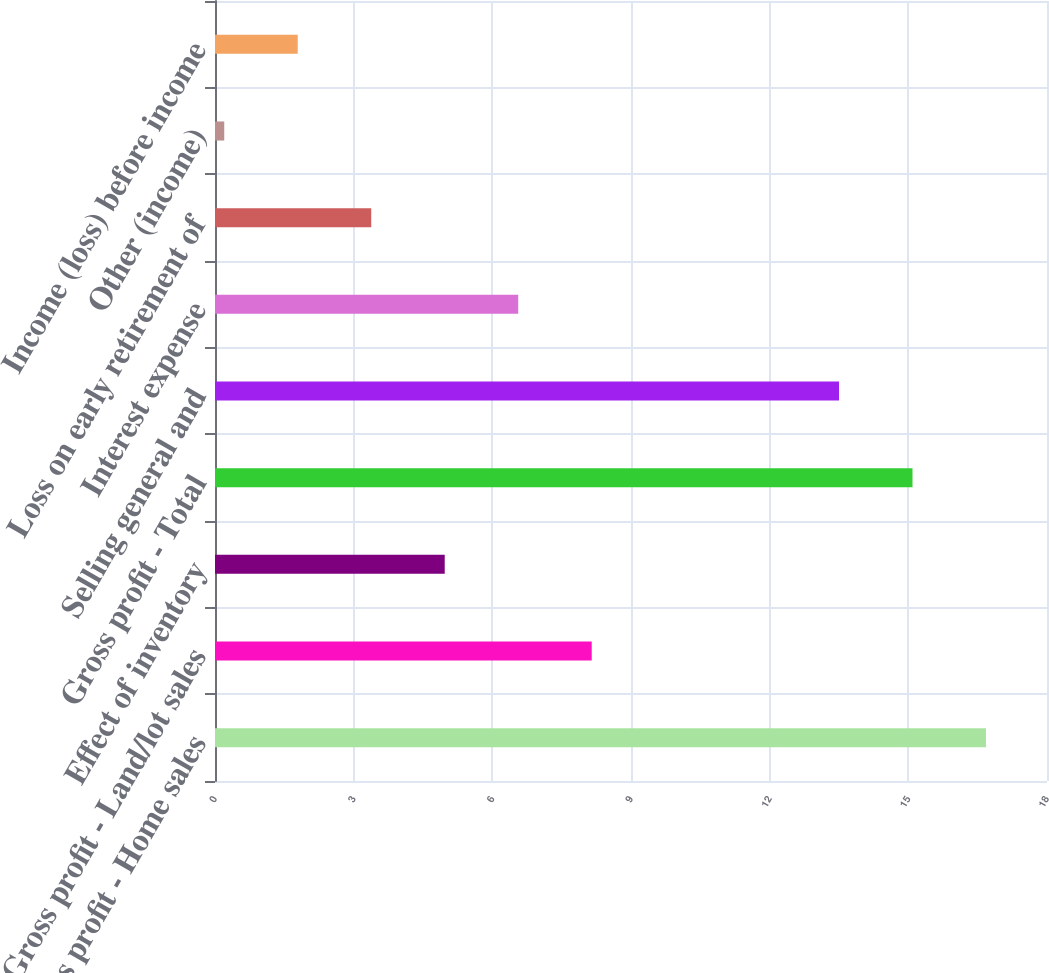Convert chart to OTSL. <chart><loc_0><loc_0><loc_500><loc_500><bar_chart><fcel>Gross profit - Home sales<fcel>Gross profit - Land/lot sales<fcel>Effect of inventory<fcel>Gross profit - Total<fcel>Selling general and<fcel>Interest expense<fcel>Loss on early retirement of<fcel>Other (income)<fcel>Income (loss) before income<nl><fcel>16.68<fcel>8.15<fcel>4.97<fcel>15.09<fcel>13.5<fcel>6.56<fcel>3.38<fcel>0.2<fcel>1.79<nl></chart> 